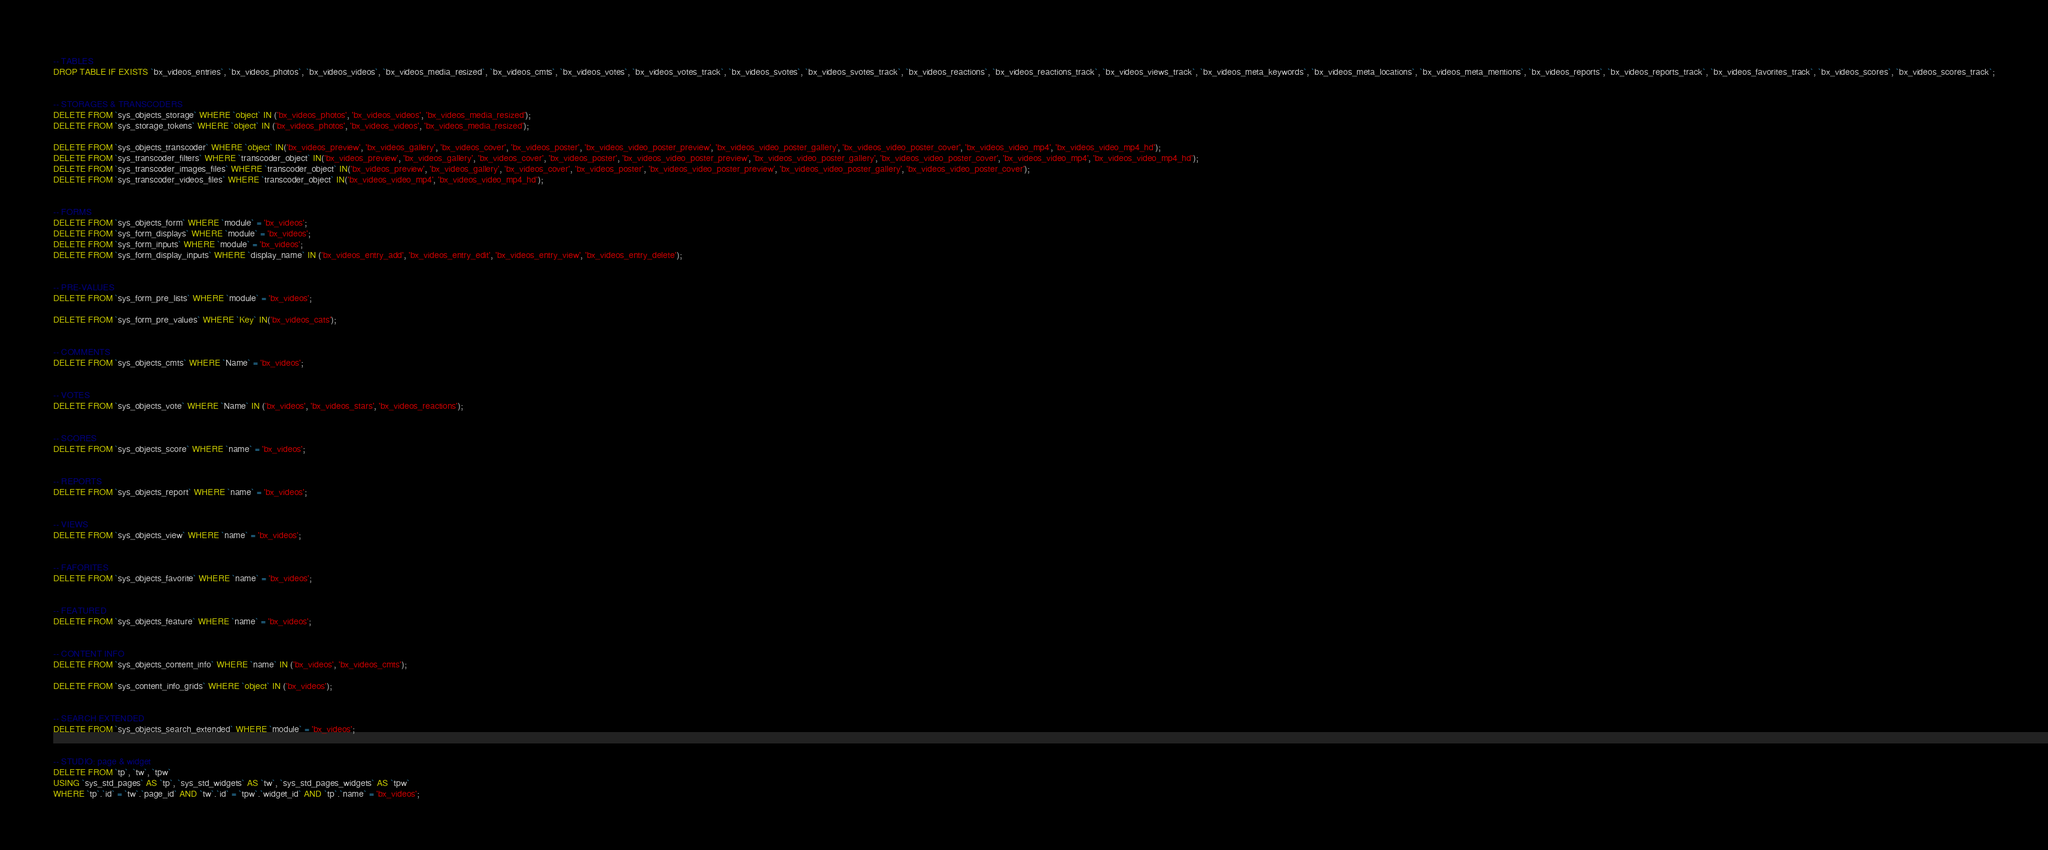Convert code to text. <code><loc_0><loc_0><loc_500><loc_500><_SQL_>
-- TABLES
DROP TABLE IF EXISTS `bx_videos_entries`, `bx_videos_photos`, `bx_videos_videos`, `bx_videos_media_resized`, `bx_videos_cmts`, `bx_videos_votes`, `bx_videos_votes_track`, `bx_videos_svotes`, `bx_videos_svotes_track`, `bx_videos_reactions`, `bx_videos_reactions_track`, `bx_videos_views_track`, `bx_videos_meta_keywords`, `bx_videos_meta_locations`, `bx_videos_meta_mentions`, `bx_videos_reports`, `bx_videos_reports_track`, `bx_videos_favorites_track`, `bx_videos_scores`, `bx_videos_scores_track`;


-- STORAGES & TRANSCODERS
DELETE FROM `sys_objects_storage` WHERE `object` IN ('bx_videos_photos', 'bx_videos_videos', 'bx_videos_media_resized');
DELETE FROM `sys_storage_tokens` WHERE `object` IN ('bx_videos_photos', 'bx_videos_videos', 'bx_videos_media_resized');

DELETE FROM `sys_objects_transcoder` WHERE `object` IN('bx_videos_preview', 'bx_videos_gallery', 'bx_videos_cover', 'bx_videos_poster', 'bx_videos_video_poster_preview', 'bx_videos_video_poster_gallery', 'bx_videos_video_poster_cover', 'bx_videos_video_mp4', 'bx_videos_video_mp4_hd');
DELETE FROM `sys_transcoder_filters` WHERE `transcoder_object` IN('bx_videos_preview', 'bx_videos_gallery', 'bx_videos_cover', 'bx_videos_poster', 'bx_videos_video_poster_preview', 'bx_videos_video_poster_gallery', 'bx_videos_video_poster_cover', 'bx_videos_video_mp4', 'bx_videos_video_mp4_hd');
DELETE FROM `sys_transcoder_images_files` WHERE `transcoder_object` IN('bx_videos_preview', 'bx_videos_gallery', 'bx_videos_cover', 'bx_videos_poster', 'bx_videos_video_poster_preview', 'bx_videos_video_poster_gallery', 'bx_videos_video_poster_cover');
DELETE FROM `sys_transcoder_videos_files` WHERE `transcoder_object` IN('bx_videos_video_mp4', 'bx_videos_video_mp4_hd');


-- FORMS
DELETE FROM `sys_objects_form` WHERE `module` = 'bx_videos';
DELETE FROM `sys_form_displays` WHERE `module` = 'bx_videos';
DELETE FROM `sys_form_inputs` WHERE `module` = 'bx_videos';
DELETE FROM `sys_form_display_inputs` WHERE `display_name` IN ('bx_videos_entry_add', 'bx_videos_entry_edit', 'bx_videos_entry_view', 'bx_videos_entry_delete');


-- PRE-VALUES
DELETE FROM `sys_form_pre_lists` WHERE `module` = 'bx_videos';

DELETE FROM `sys_form_pre_values` WHERE `Key` IN('bx_videos_cats');


-- COMMENTS
DELETE FROM `sys_objects_cmts` WHERE `Name` = 'bx_videos';


-- VOTES
DELETE FROM `sys_objects_vote` WHERE `Name` IN ('bx_videos', 'bx_videos_stars', 'bx_videos_reactions');


-- SCORES
DELETE FROM `sys_objects_score` WHERE `name` = 'bx_videos';


-- REPORTS
DELETE FROM `sys_objects_report` WHERE `name` = 'bx_videos';


-- VIEWS
DELETE FROM `sys_objects_view` WHERE `name` = 'bx_videos';


-- FAFORITES
DELETE FROM `sys_objects_favorite` WHERE `name` = 'bx_videos';


-- FEATURED
DELETE FROM `sys_objects_feature` WHERE `name` = 'bx_videos';


-- CONTENT INFO
DELETE FROM `sys_objects_content_info` WHERE `name` IN ('bx_videos', 'bx_videos_cmts');

DELETE FROM `sys_content_info_grids` WHERE `object` IN ('bx_videos');


-- SEARCH EXTENDED
DELETE FROM `sys_objects_search_extended` WHERE `module` = 'bx_videos';


-- STUDIO: page & widget
DELETE FROM `tp`, `tw`, `tpw`
USING `sys_std_pages` AS `tp`, `sys_std_widgets` AS `tw`, `sys_std_pages_widgets` AS `tpw`
WHERE `tp`.`id` = `tw`.`page_id` AND `tw`.`id` = `tpw`.`widget_id` AND `tp`.`name` = 'bx_videos';
</code> 